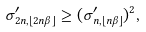<formula> <loc_0><loc_0><loc_500><loc_500>\sigma ^ { \prime } _ { 2 n , \lfloor 2 n \beta \rfloor } \geq ( \sigma ^ { \prime } _ { n , \lfloor n \beta \rfloor } ) ^ { 2 } ,</formula> 